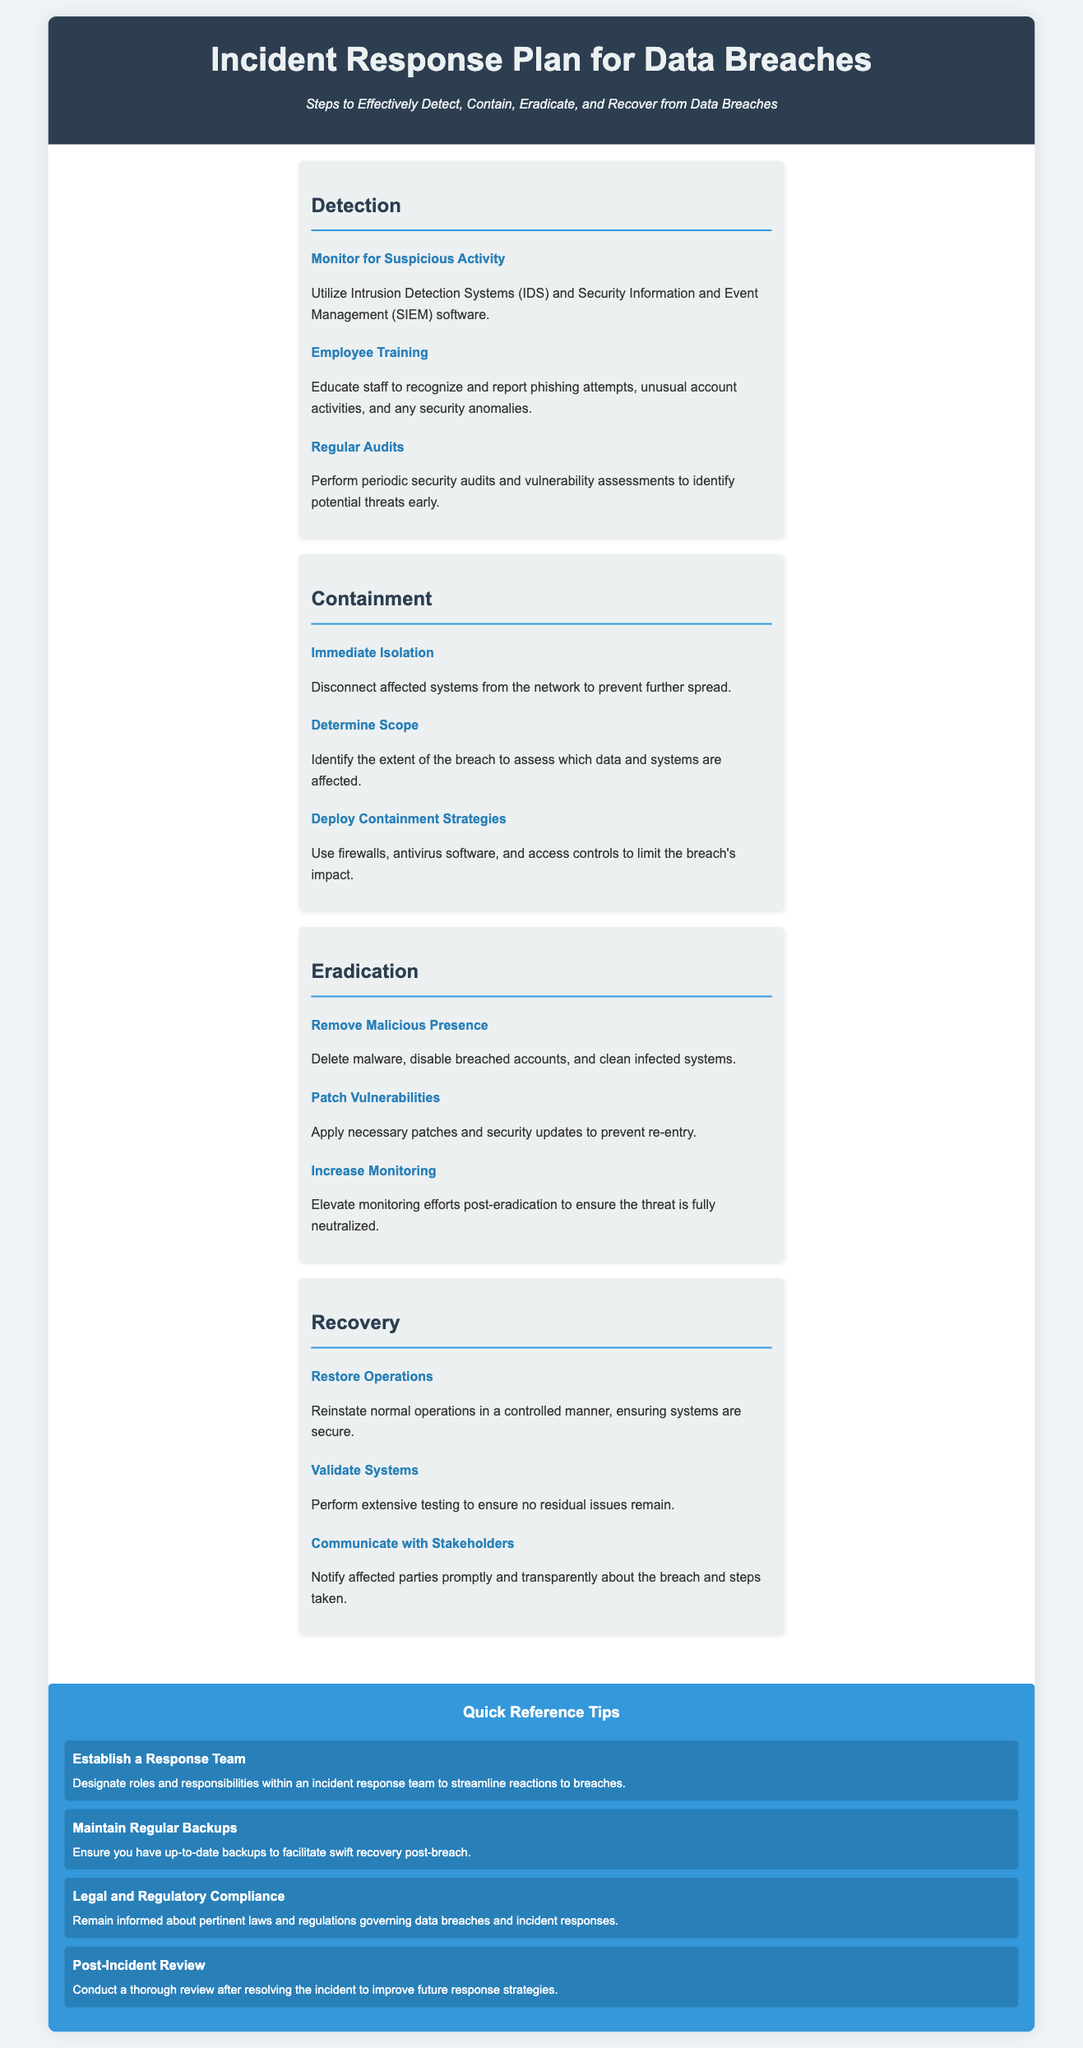what are the main steps in an incident response plan? The document outlines four main steps in the incident response plan: Detection, Containment, Eradication, and Recovery.
Answer: Detection, Containment, Eradication, Recovery what should be monitored for suspicious activity? The document suggests utilizing Intrusion Detection Systems (IDS) and Security Information and Event Management (SIEM) software for monitoring.
Answer: IDS and SIEM what is an immediate action to take during containment? The document states to immediately disconnect affected systems from the network to prevent further spread.
Answer: Disconnect affected systems how should vulnerabilities be addressed during eradication? It is indicated in the document that necessary patches and security updates should be applied to prevent re-entry.
Answer: Apply necessary patches what is a quick reference tip regarding backup? The document encourages maintaining regular backups to facilitate swift recovery post-breach.
Answer: Maintain regular backups what is a necessary action communication-wise after recovery? The document emphasizes the need to notify affected parties promptly and transparently about the breach and steps taken.
Answer: Notify affected parties how often should audits be performed? Regular audits should be performed periodically, according to the document's information.
Answer: Periodically what role do employee trainings play in detection? The document highlights educating staff to recognize and report phishing attempts and security anomalies as a crucial part of detection.
Answer: Recognize and report security anomalies what can be deployed to limit the breach's impact? Firewalls, antivirus software, and access controls can be deployed as per the containment strategies mentioned in the document.
Answer: Firewalls, antivirus software, access controls 